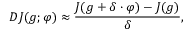<formula> <loc_0><loc_0><loc_500><loc_500>D J ( g ; \varphi ) \approx \frac { J ( g + \delta \cdot \varphi ) - J ( g ) } { \delta } ,</formula> 